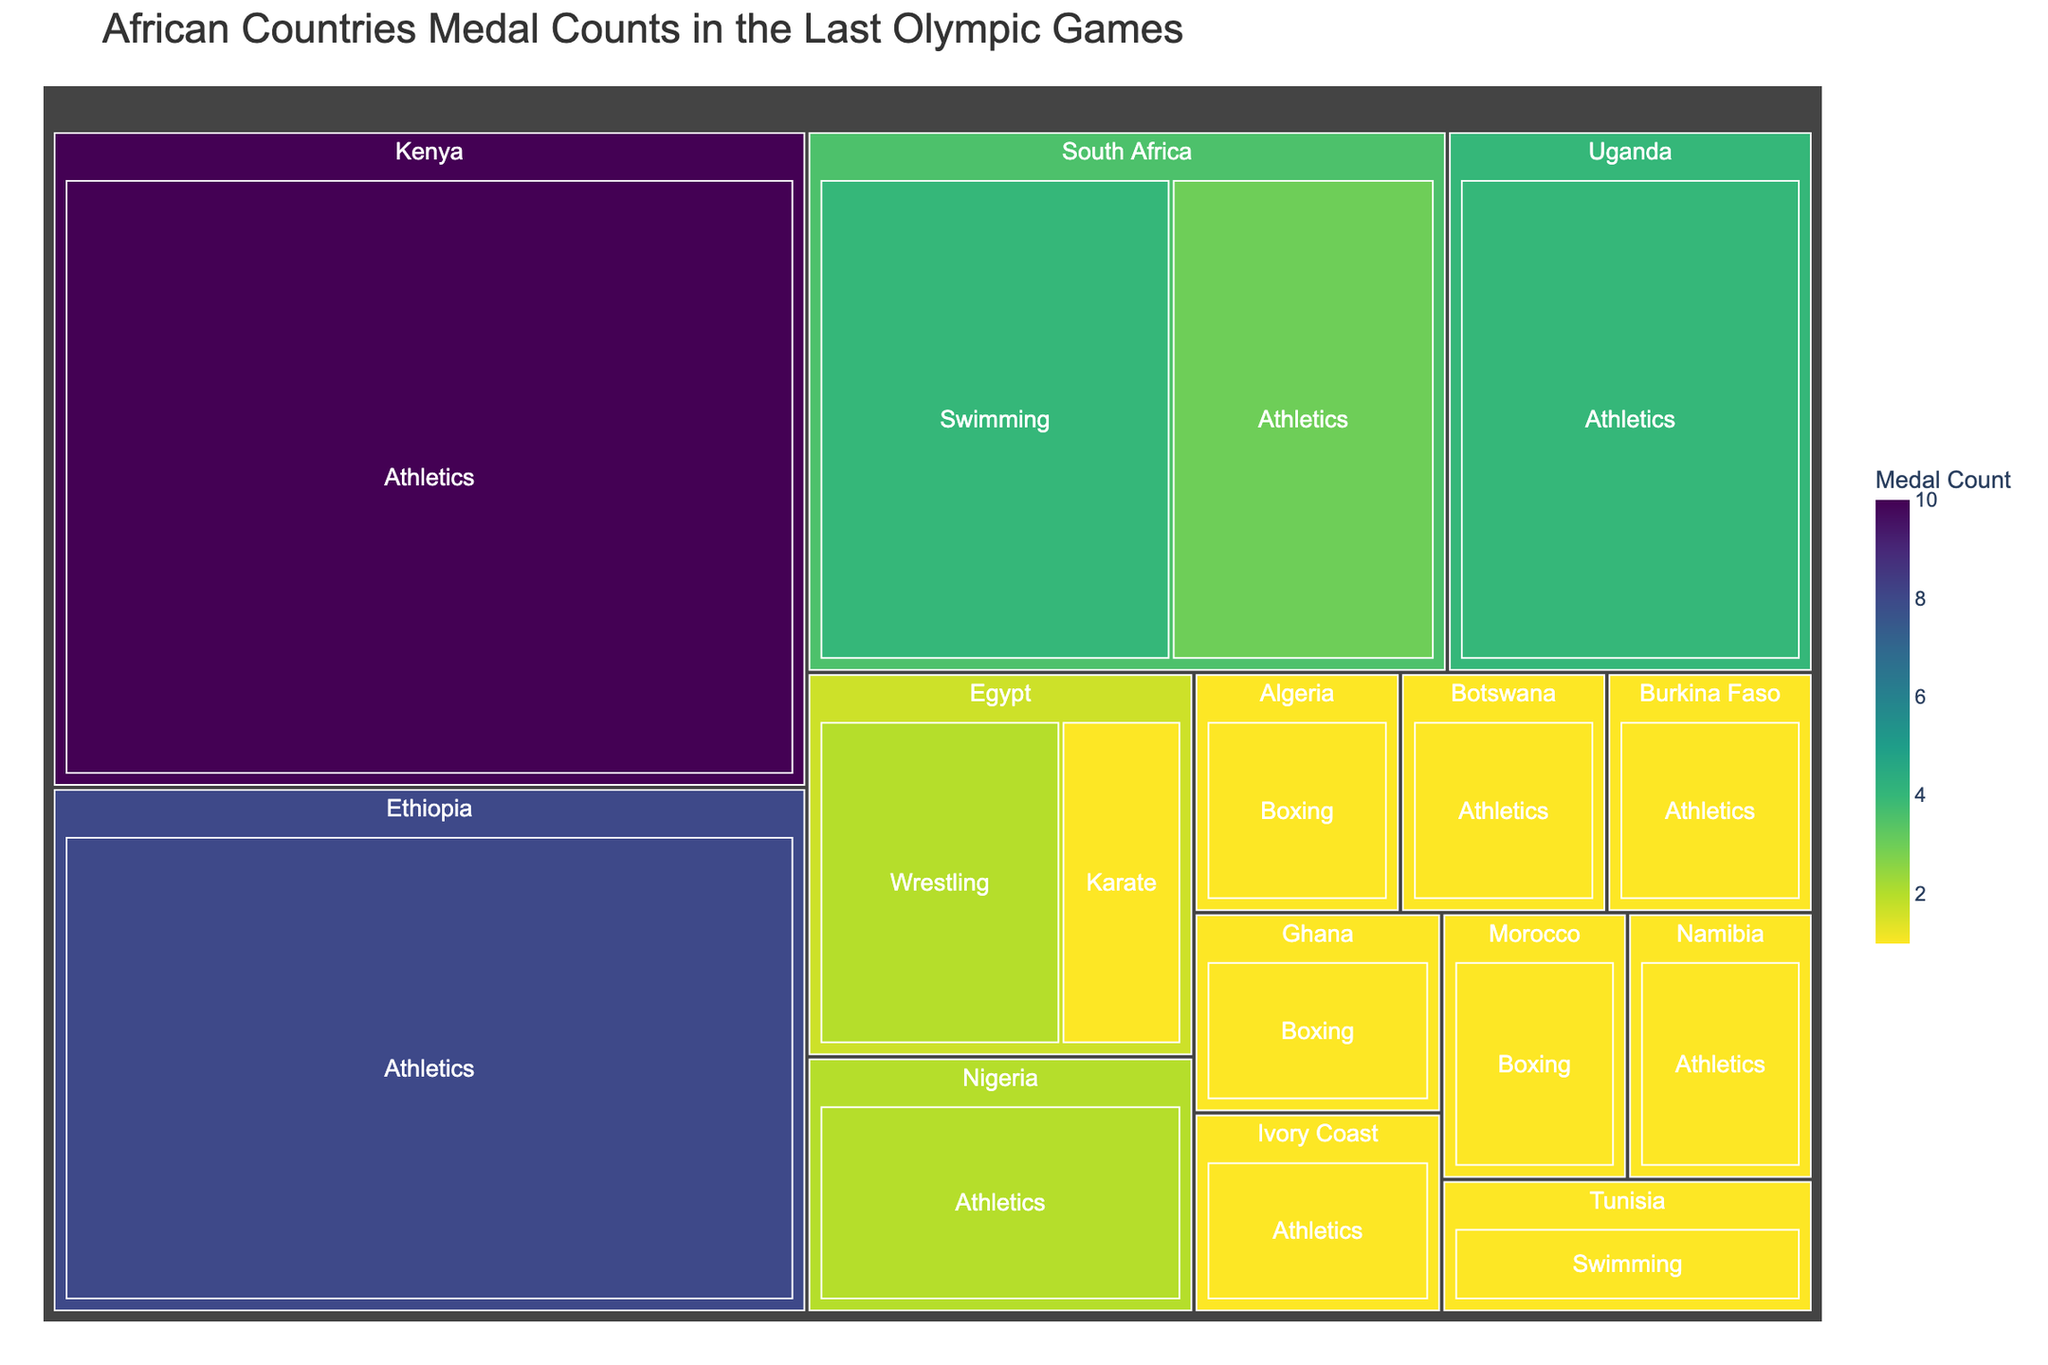How many medals did Kenya win in total? Locate the section representing Kenya in the treemap. Sum the medals within Kenya's category. From the data, Kenya won 10 medals in Athletics.
Answer: 10 Which country won the highest number of medals, and how many? Identify the sections of the treemap representing each country and compare their medal counts. Kenya has the largest section with 10 medals.
Answer: Kenya, 10 Which sport contributed the most medals for South Africa? Focus on the sections under South Africa in the treemap. Compare the medal counts for each sport. Swimming has 4 medals and Athletics has 3 medals, so Swimming contributed the most.
Answer: Swimming How many African countries won medals in Athletics? Identify and count the distinct countries from the sections labeled Athletics. According to the data, Kenya, South Africa, Ethiopia, Uganda, Nigeria, Ivory Coast, Namibia, Botswana, Burkina Faso participated in Athletics.
Answer: 9 What is the combined total of medals won by Egypt? Look at the sections under Egypt in the treemap. Sum the medals for Wrestling (2) and Karate (1) to get the combined total. 2 + 1 = 3
Answer: 3 Which countries won medals in Boxing, and how many did each win? Locate the sections representing Boxing in the treemap and identify the countries. Morocco, Ghana, Algeria each won 1 medal.
Answer: Morocco, Ghana, Algeria each won 1 Compare the medal counts between Uganda and Ethiopia. Which country won more, and by how many medals? Look at the sections under Uganda and Ethiopia in the treemap. Uganda won 4 medals, and Ethiopia won 8 medals. Ethiopia won 4 more medals than Uganda.
Answer: Ethiopia, by 4 medals Which sport had the highest medal count, and what is that count? Identify all sports in the treemap, sum the medals for each, and compare. Athletics has the highest count. Summing the data: 10 (Kenya) + 3 (South Africa) + 8 (Ethiopia) + 4 (Uganda) + 2 (Nigeria) + 1 (Ivory Coast) + 1 (Namibia) + 1 (Botswana) + 1 (Burkina Faso) = 31
Answer: Athletics, 31 If you combine the medals from Nigeria and Tunisia, how many medals do they have together? Locate the sections under Nigeria and Tunisia in the treemap. Nigeria has 2 medals, and Tunisia has 1. Sum them up: 2 + 1 = 3
Answer: 3 How many sports did the most decorated country (Kenya) win medals in? Inspect Kenya's section in the treemap. Kenya competed in only one sport, Athletics.
Answer: 1 